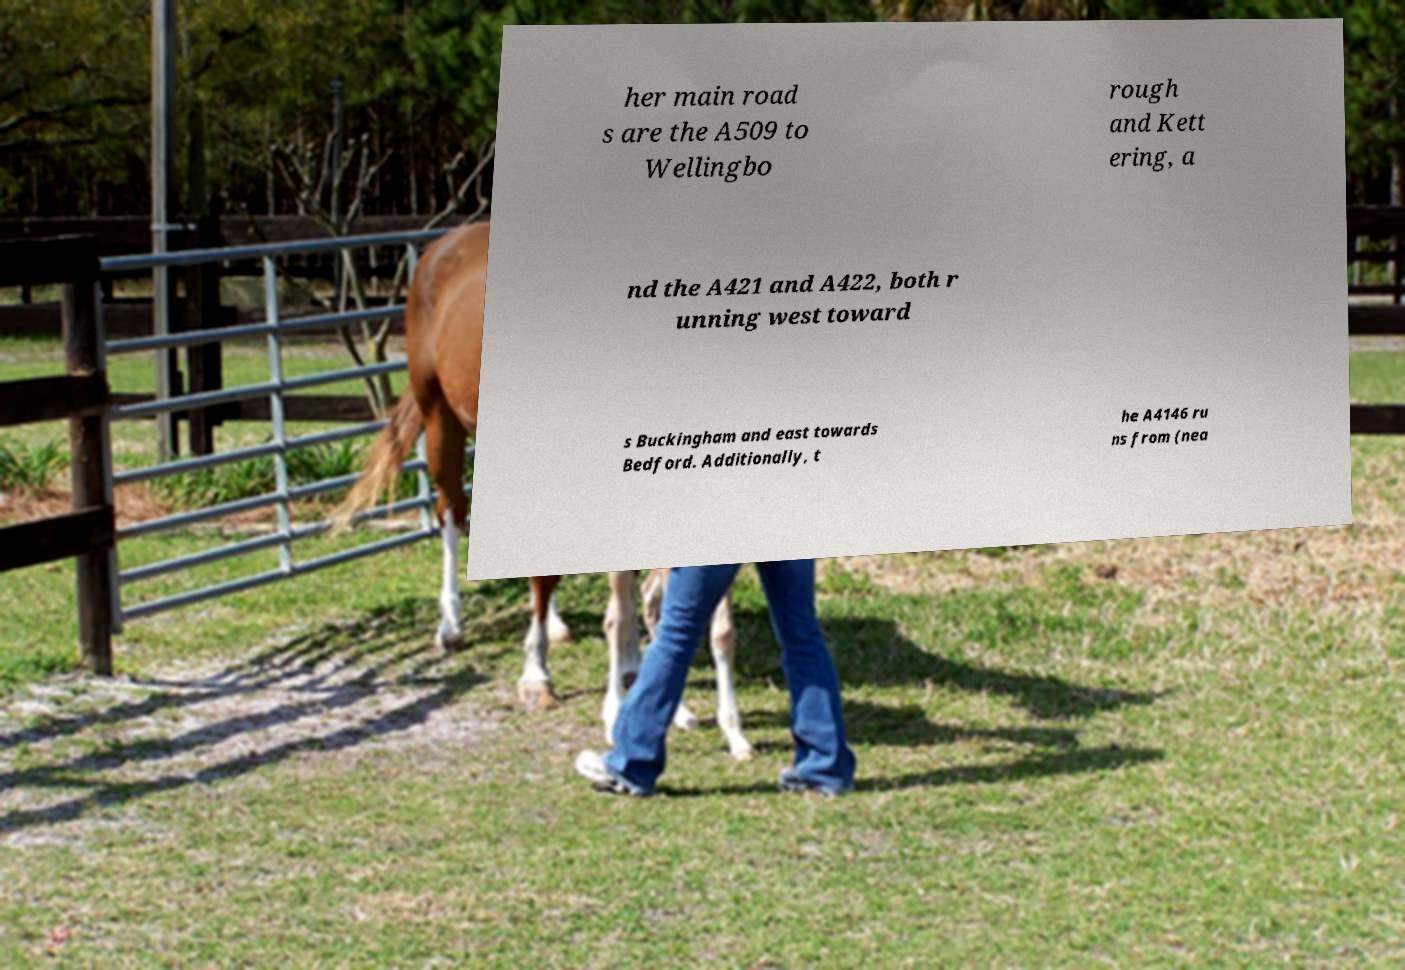There's text embedded in this image that I need extracted. Can you transcribe it verbatim? her main road s are the A509 to Wellingbo rough and Kett ering, a nd the A421 and A422, both r unning west toward s Buckingham and east towards Bedford. Additionally, t he A4146 ru ns from (nea 